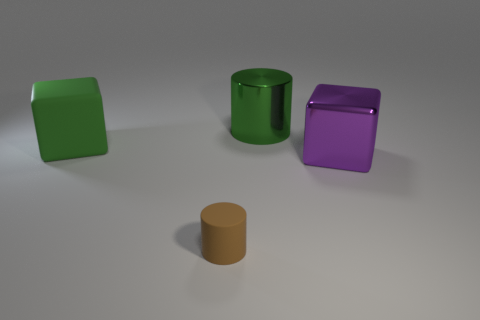Are there any tiny cylinders? Yes, there's a small, tan-colored cylinder in the foreground on the right. 